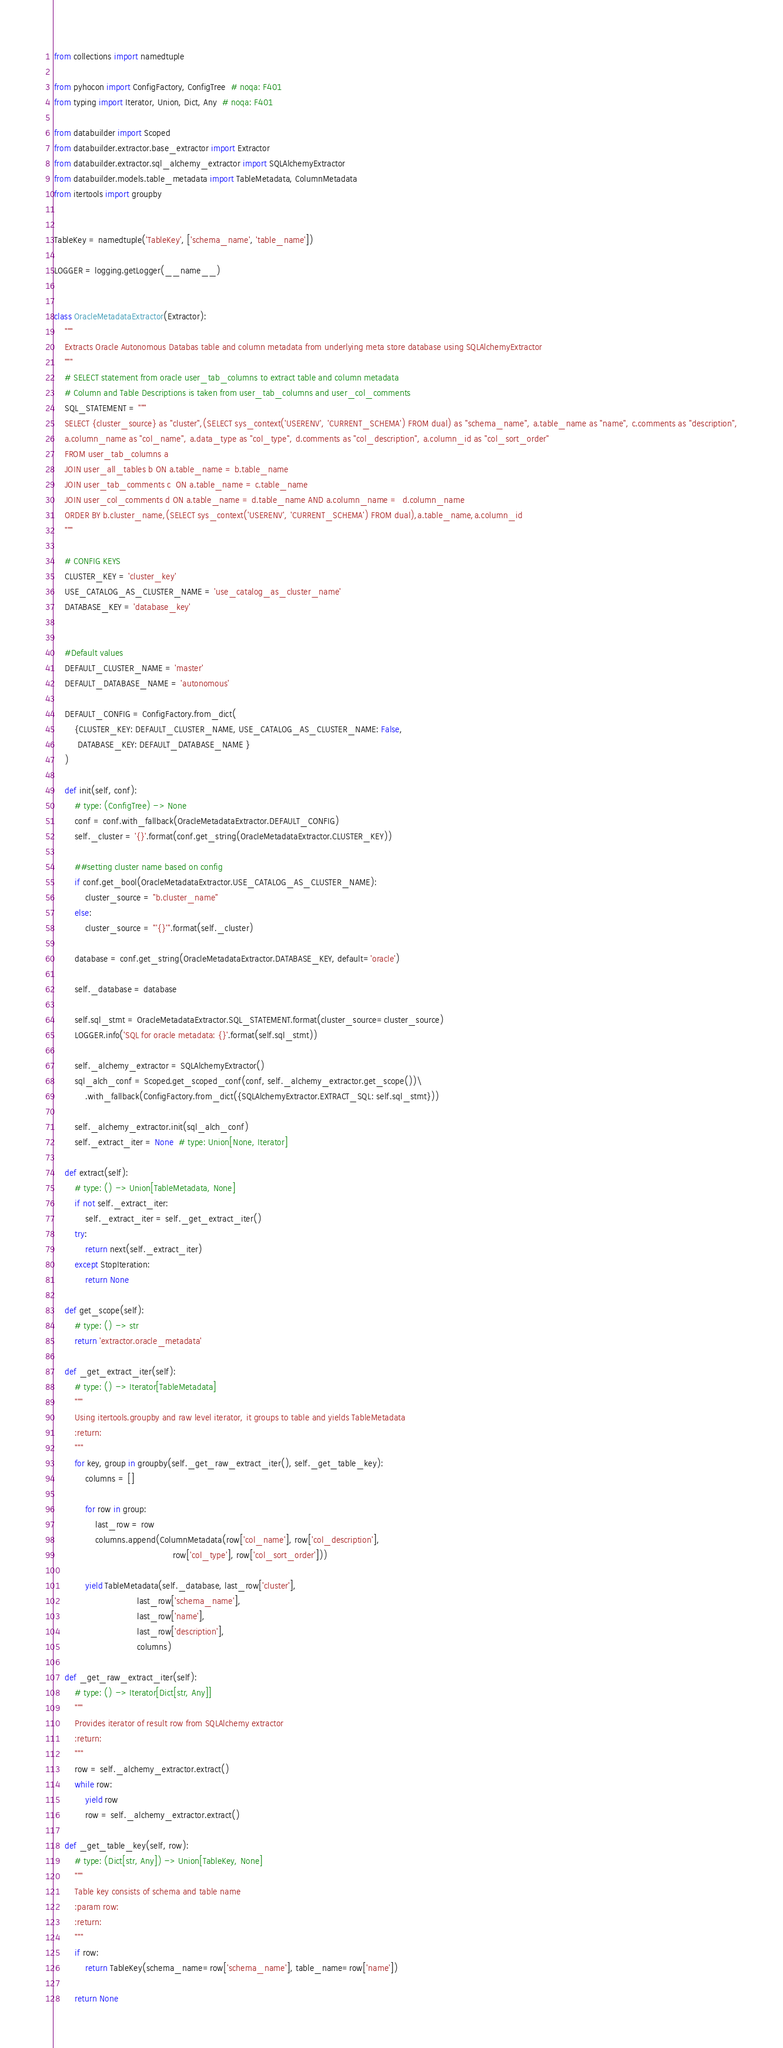Convert code to text. <code><loc_0><loc_0><loc_500><loc_500><_Python_>
from collections import namedtuple

from pyhocon import ConfigFactory, ConfigTree  # noqa: F401
from typing import Iterator, Union, Dict, Any  # noqa: F401

from databuilder import Scoped
from databuilder.extractor.base_extractor import Extractor
from databuilder.extractor.sql_alchemy_extractor import SQLAlchemyExtractor
from databuilder.models.table_metadata import TableMetadata, ColumnMetadata
from itertools import groupby


TableKey = namedtuple('TableKey', ['schema_name', 'table_name'])

LOGGER = logging.getLogger(__name__)


class OracleMetadataExtractor(Extractor):
    """
    Extracts Oracle Autonomous Databas table and column metadata from underlying meta store database using SQLAlchemyExtractor
    """
    # SELECT statement from oracle user_tab_columns to extract table and column metadata
    # Column and Table Descriptions is taken from user_tab_columns and user_col_comments
    SQL_STATEMENT = """
    SELECT {cluster_source} as "cluster",(SELECT sys_context('USERENV', 'CURRENT_SCHEMA') FROM dual) as "schema_name", a.table_name as "name", c.comments as "description",
    a.column_name as "col_name", a.data_type as "col_type", d.comments as "col_description", a.column_id as "col_sort_order"
    FROM user_tab_columns a
    JOIN user_all_tables b ON a.table_name = b.table_name
    JOIN user_tab_comments c  ON a.table_name = c.table_name
    JOIN user_col_comments d ON a.table_name = d.table_name AND a.column_name =  d.column_name
    ORDER BY b.cluster_name,(SELECT sys_context('USERENV', 'CURRENT_SCHEMA') FROM dual),a.table_name,a.column_id
    """

    # CONFIG KEYS
    CLUSTER_KEY = 'cluster_key'
    USE_CATALOG_AS_CLUSTER_NAME = 'use_catalog_as_cluster_name'
    DATABASE_KEY = 'database_key'


    #Default values
    DEFAULT_CLUSTER_NAME = 'master'
    DEFAULT_DATABASE_NAME = 'autonomous'

    DEFAULT_CONFIG = ConfigFactory.from_dict(
        {CLUSTER_KEY: DEFAULT_CLUSTER_NAME, USE_CATALOG_AS_CLUSTER_NAME: False,
         DATABASE_KEY: DEFAULT_DATABASE_NAME }
    )

    def init(self, conf):
        # type: (ConfigTree) -> None
        conf = conf.with_fallback(OracleMetadataExtractor.DEFAULT_CONFIG)
        self._cluster = '{}'.format(conf.get_string(OracleMetadataExtractor.CLUSTER_KEY))

        ##setting cluster name based on config
        if conf.get_bool(OracleMetadataExtractor.USE_CATALOG_AS_CLUSTER_NAME):
            cluster_source = "b.cluster_name"
        else:
            cluster_source = "'{}'".format(self._cluster)

        database = conf.get_string(OracleMetadataExtractor.DATABASE_KEY, default='oracle')

        self._database = database

        self.sql_stmt = OracleMetadataExtractor.SQL_STATEMENT.format(cluster_source=cluster_source)
        LOGGER.info('SQL for oracle metadata: {}'.format(self.sql_stmt))

        self._alchemy_extractor = SQLAlchemyExtractor()
        sql_alch_conf = Scoped.get_scoped_conf(conf, self._alchemy_extractor.get_scope())\
            .with_fallback(ConfigFactory.from_dict({SQLAlchemyExtractor.EXTRACT_SQL: self.sql_stmt}))

        self._alchemy_extractor.init(sql_alch_conf)
        self._extract_iter = None  # type: Union[None, Iterator]

    def extract(self):
        # type: () -> Union[TableMetadata, None]
        if not self._extract_iter:
            self._extract_iter = self._get_extract_iter()
        try:
            return next(self._extract_iter)
        except StopIteration:
            return None

    def get_scope(self):
        # type: () -> str
        return 'extractor.oracle_metadata'

    def _get_extract_iter(self):
        # type: () -> Iterator[TableMetadata]
        """
        Using itertools.groupby and raw level iterator, it groups to table and yields TableMetadata
        :return:
        """
        for key, group in groupby(self._get_raw_extract_iter(), self._get_table_key):
            columns = []

            for row in group:
                last_row = row
                columns.append(ColumnMetadata(row['col_name'], row['col_description'],
                                              row['col_type'], row['col_sort_order']))

            yield TableMetadata(self._database, last_row['cluster'],
                                last_row['schema_name'],
                                last_row['name'],
                                last_row['description'],
                                columns)

    def _get_raw_extract_iter(self):
        # type: () -> Iterator[Dict[str, Any]]
        """
        Provides iterator of result row from SQLAlchemy extractor
        :return:
        """
        row = self._alchemy_extractor.extract()
        while row:
            yield row
            row = self._alchemy_extractor.extract()

    def _get_table_key(self, row):
        # type: (Dict[str, Any]) -> Union[TableKey, None]
        """
        Table key consists of schema and table name
        :param row:
        :return:
        """
        if row:
            return TableKey(schema_name=row['schema_name'], table_name=row['name'])

        return None
</code> 